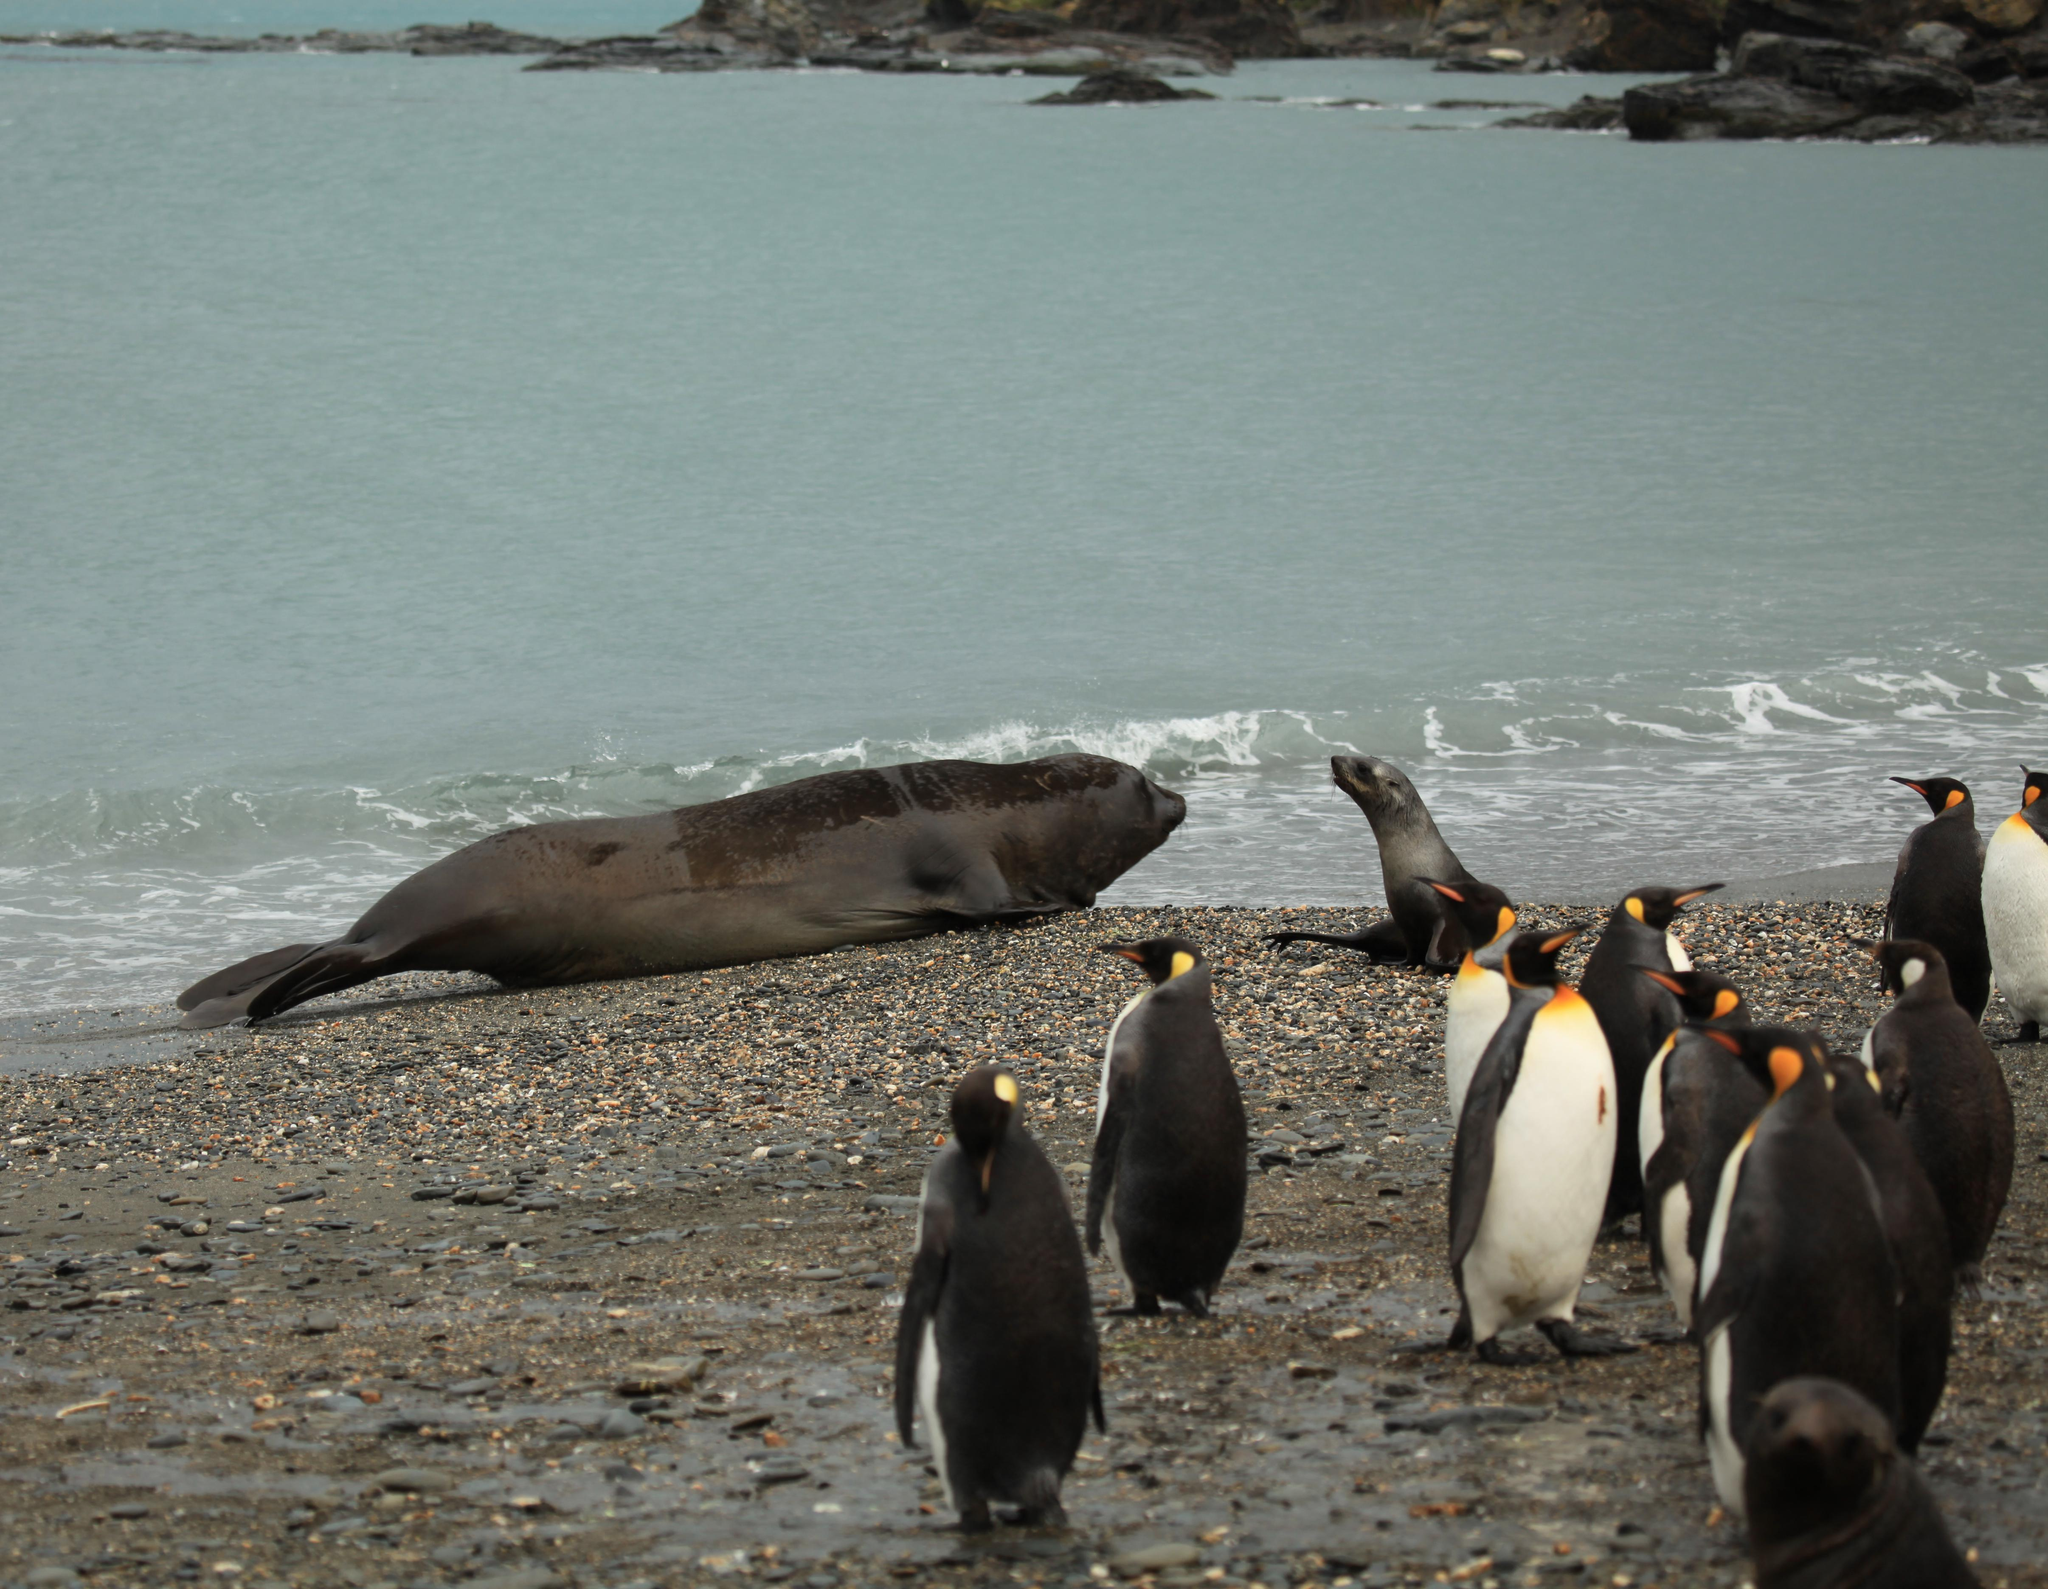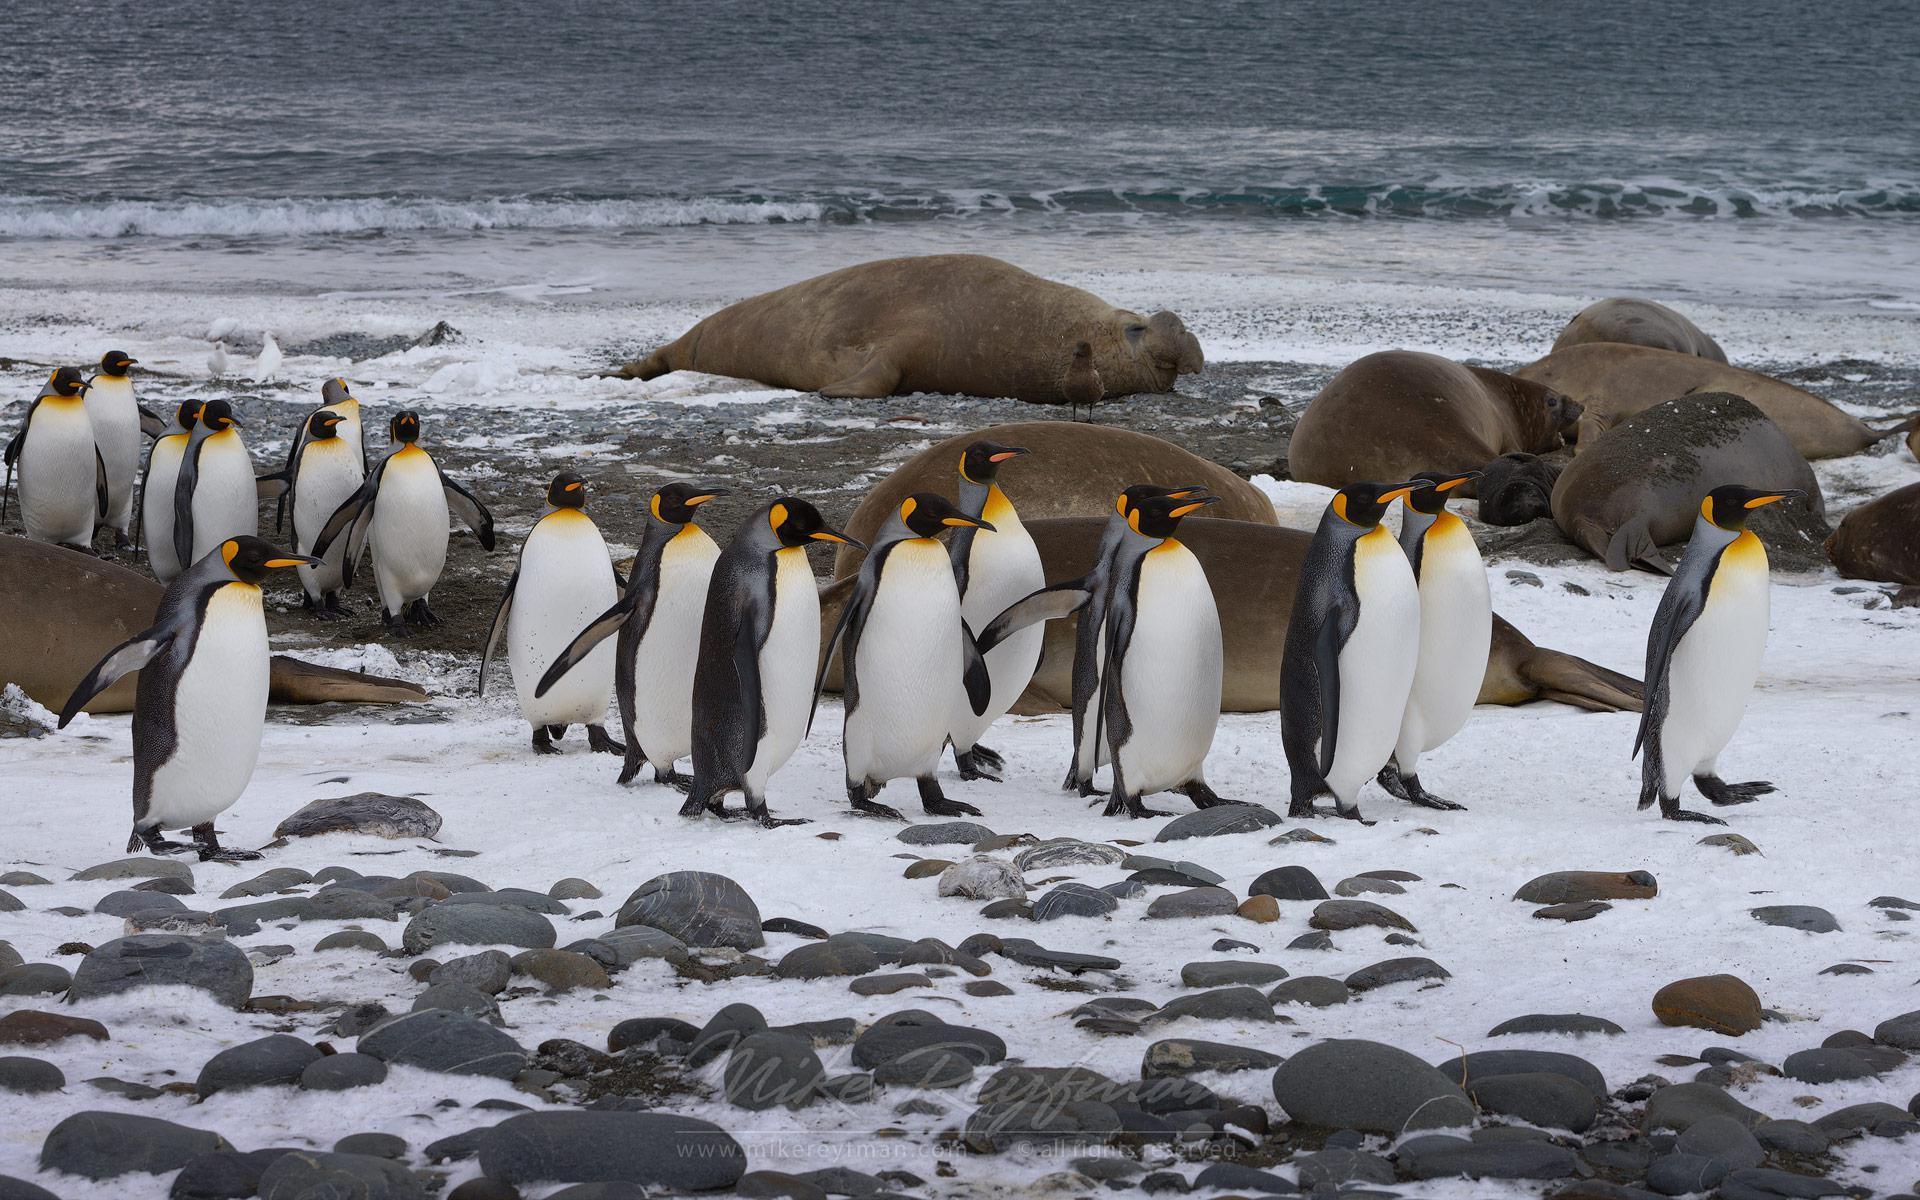The first image is the image on the left, the second image is the image on the right. Evaluate the accuracy of this statement regarding the images: "In this image only land and sky are visible along side at least 8 penguins and a single sea lion.". Is it true? Answer yes or no. No. The first image is the image on the left, the second image is the image on the right. Examine the images to the left and right. Is the description "There is a group of penguins standing near the water's edge with no bird in the forefront." accurate? Answer yes or no. Yes. 